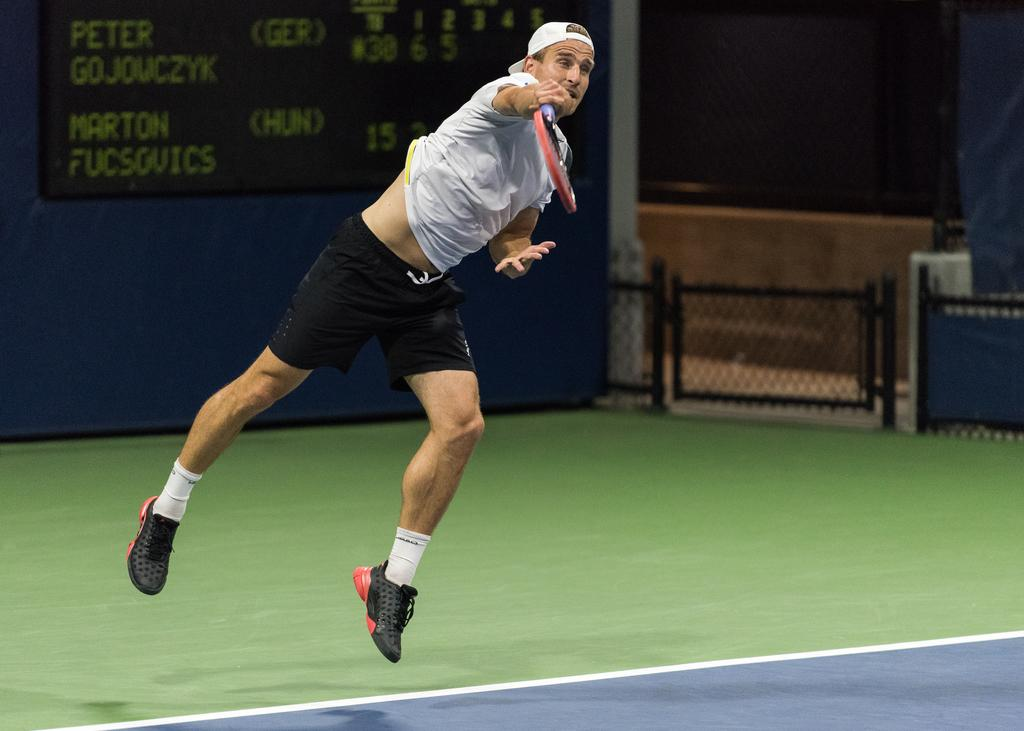What is the man in the image doing? The man is jumping and playing tennis in the image. What object is the man holding while playing tennis? The man is holding a tennis racket in the image. What can be seen in the background of the image? There is a scoreboard in the background of the image. What architectural feature is visible in the image? There is a small gate visible in the image. What type of juice is the man drinking while playing tennis in the image? There is no juice present in the image; the man is playing tennis and holding a tennis racket. 